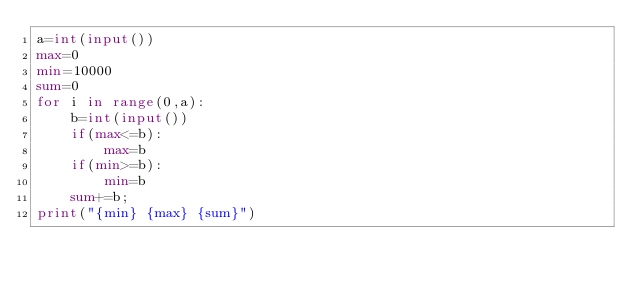<code> <loc_0><loc_0><loc_500><loc_500><_Python_>a=int(input())
max=0
min=10000
sum=0
for i in range(0,a):
    b=int(input())
    if(max<=b):
        max=b
    if(min>=b):
        min=b
    sum+=b;
print("{min} {max} {sum}")
    
</code> 